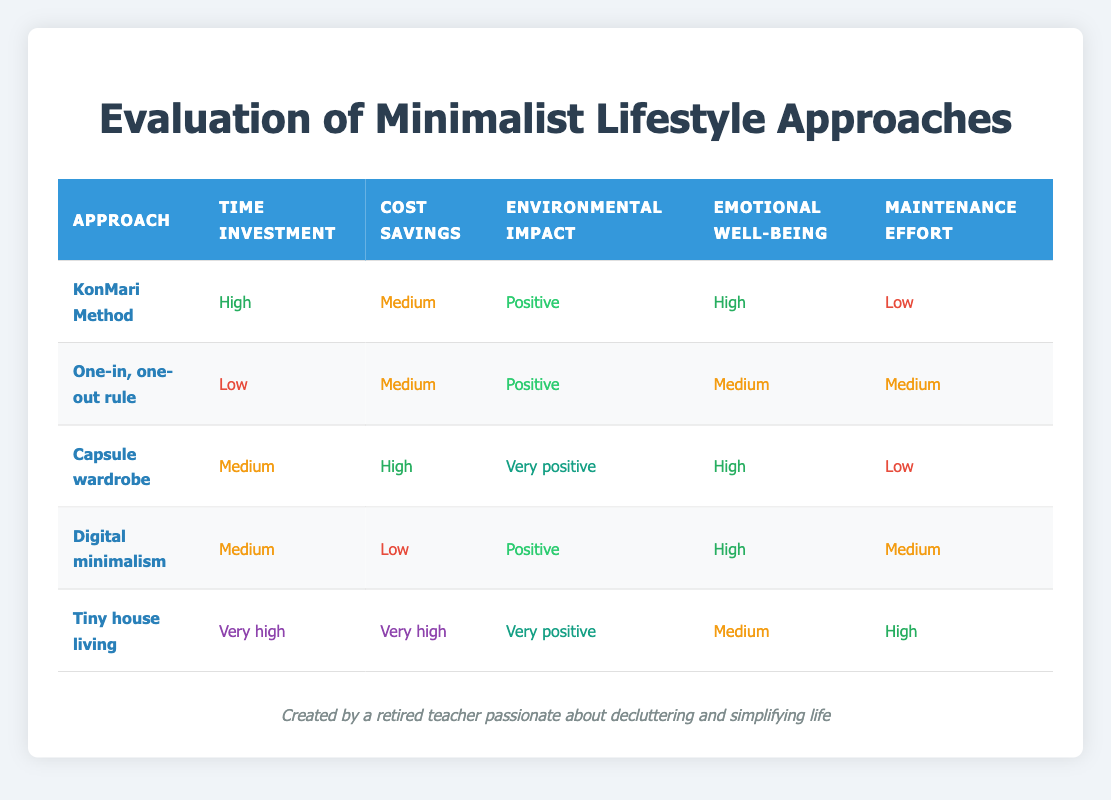What is the time investment for the Capsule wardrobe approach? The Capsule wardrobe approach has a time investment categorized as Medium based on the table data.
Answer: Medium Which approach has the highest emotional well-being rating? The KonMari Method and Capsule wardrobe both have a high rating for emotional well-being. Based on the evaluations, they are the only approaches listed with "High" under that criterion.
Answer: KonMari Method and Capsule wardrobe Does the Tiny house living approach have a very high cost savings? Yes, the Tiny house living approach has been evaluated with a very high rating for cost savings in the table.
Answer: Yes Which approach has the lowest maintenance effort? Both the KonMari Method and Capsule wardrobe have the lowest maintenance effort categorized as Low.
Answer: KonMari Method and Capsule wardrobe What is the difference in environmental impact ratings between Digital minimalism and Tiny house living? Digital minimalism has a rating of Positive while Tiny house living has a rating of Very positive. The difference in their ratings indicates that Tiny house living has a better environmental impact than Digital minimalism.
Answer: One level (Positive to Very positive) Which minimalist approach requires the most time investment, and what is that classification? The Tiny house living approach requires the most time investment, classified as Very high. This is clear from the evaluated data.
Answer: Very high Is cost savings highest for the One-in, one-out rule? No, the One-in, one-out rule has a medium cost savings rating, which is not the highest compared to other approaches like Capsule wardrobe and Tiny house living.
Answer: No What are the overall emotional well-being ratings for approaches with a positive environmental impact? The approaches with a positive environmental impact are KonMari Method, One-in one-out rule, and Digital minimalism. Their emotional well-being ratings are High, Medium, and High respectively. The average ratings for these approaches are (High + Medium + High) = 2 High and 1 Medium.
Answer: 2 High and 1 Medium 